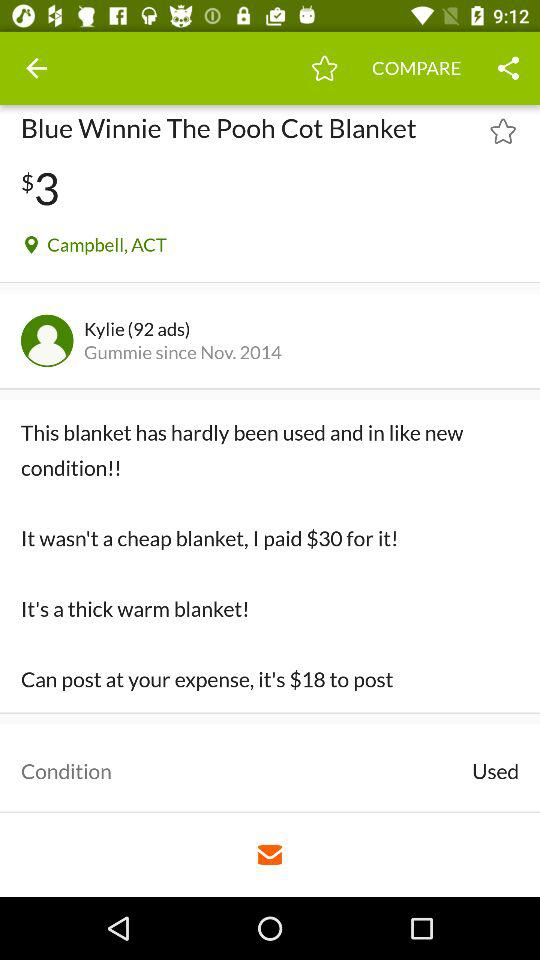What is the location of the "Blue Winnie The Pooh Cot Blanket"? The location is Campbell, ACT. 